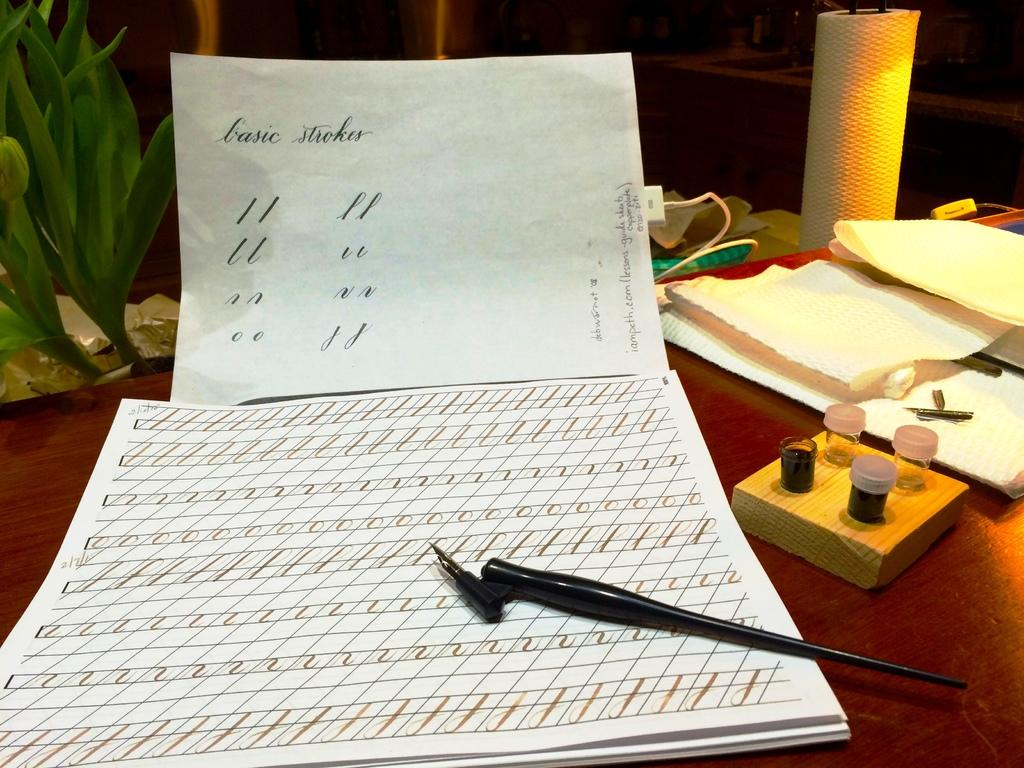What type of objects can be seen with writing or symbols in the image? There are papers with symbols and text in the image. What tool is present for writing or drawing? There is a pen with a nib in the image. What might be used for refilling the pen with ink? There are ink bottles in the image. What else can be seen on the papers in the image? There are other papers in the image. What device is present for charging electronic items? There is a charger in the image. What living organism is present in the image? There is a potted plant in the image. How many snakes are coiled around the pen in the image? There are no snakes present in the image; the pen is not associated with any snakes. What type of canvas is visible in the image? There is no canvas present in the image. 